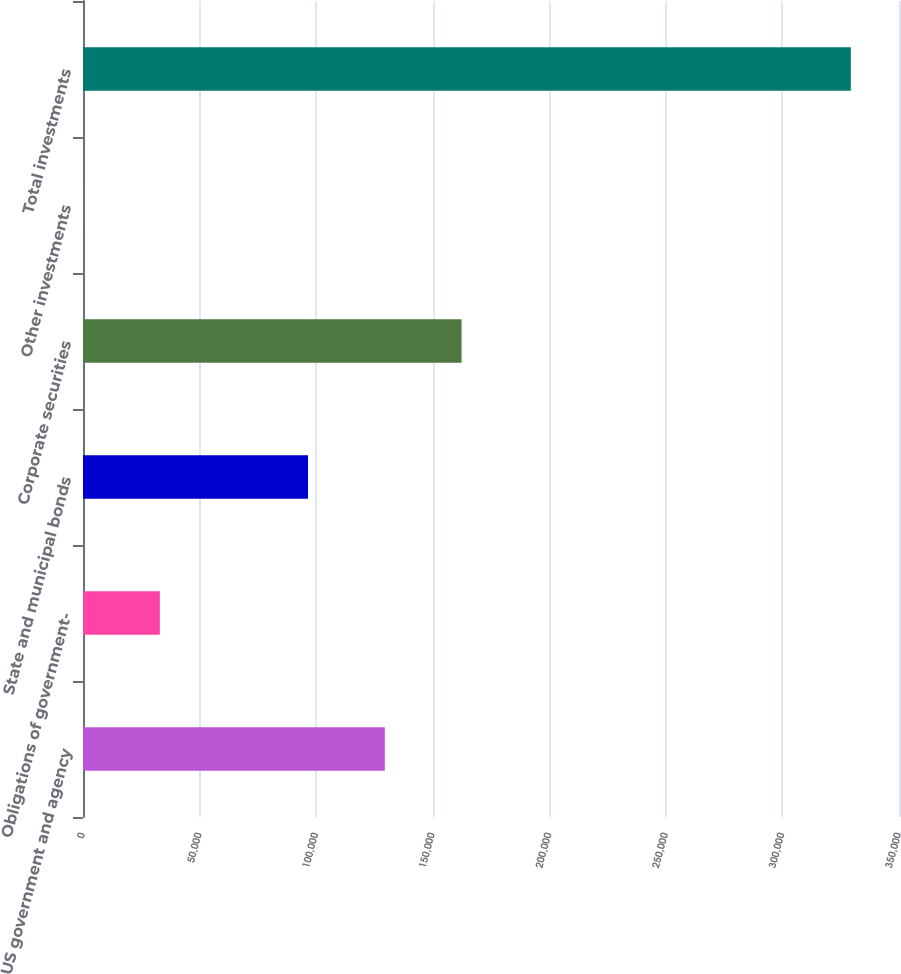Convert chart. <chart><loc_0><loc_0><loc_500><loc_500><bar_chart><fcel>US government and agency<fcel>Obligations of government-<fcel>State and municipal bonds<fcel>Corporate securities<fcel>Other investments<fcel>Total investments<nl><fcel>129446<fcel>32965.9<fcel>96516<fcel>162376<fcel>36<fcel>329335<nl></chart> 